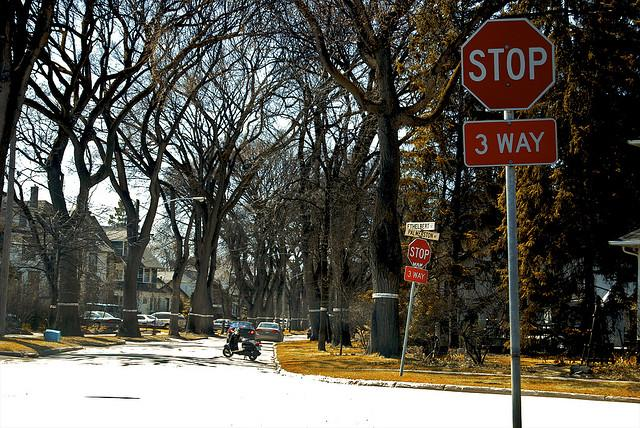How many ways are there on this stop sign? Please explain your reasoning. three. The sign clearly states how many ways there are to stop. 